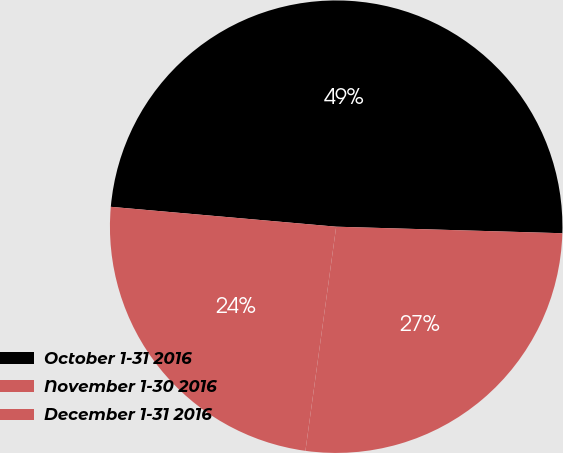Convert chart. <chart><loc_0><loc_0><loc_500><loc_500><pie_chart><fcel>October 1-31 2016<fcel>November 1-30 2016<fcel>December 1-31 2016<nl><fcel>49.06%<fcel>26.71%<fcel>24.23%<nl></chart> 